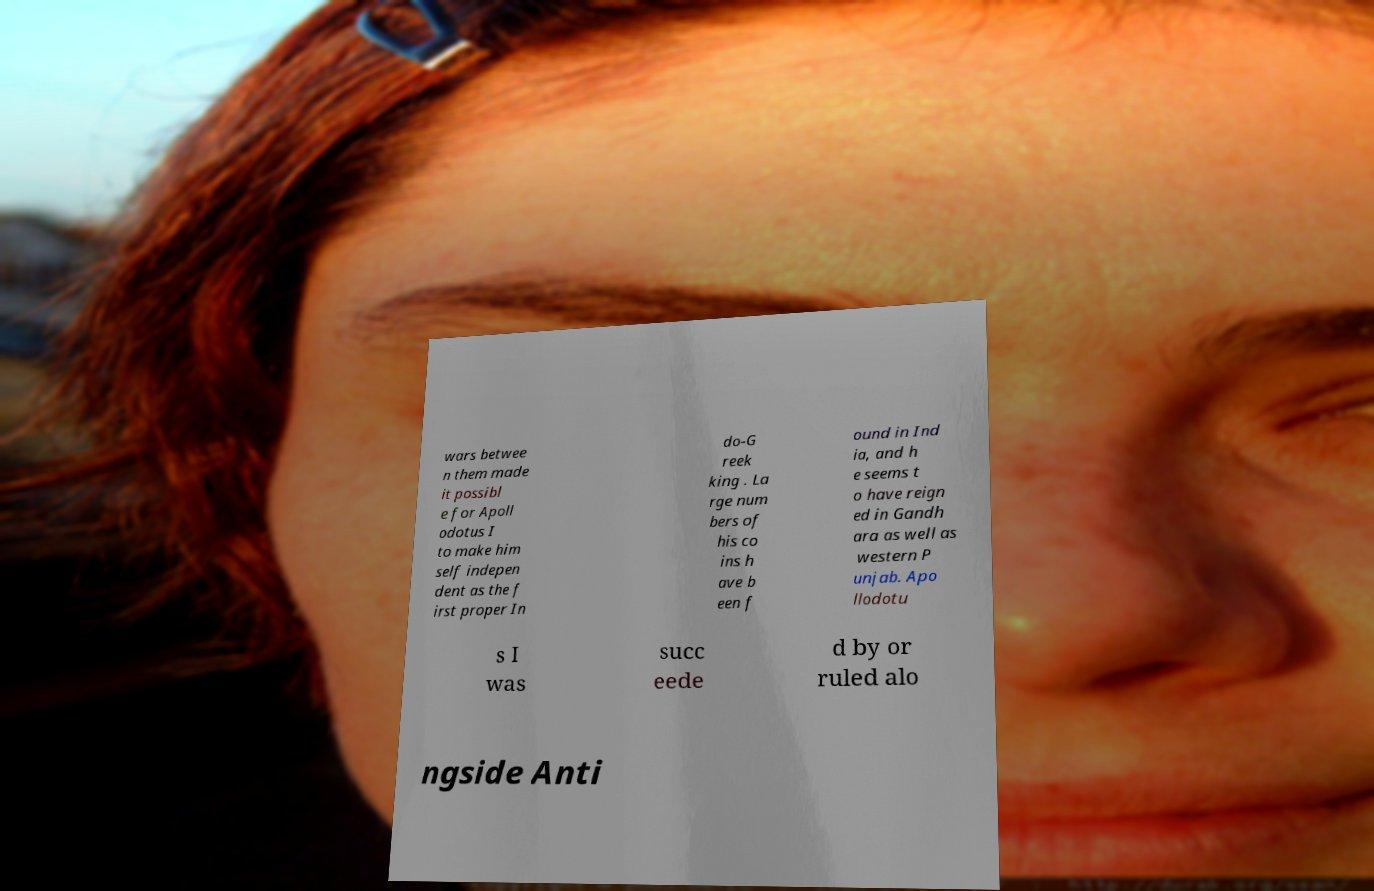Could you extract and type out the text from this image? wars betwee n them made it possibl e for Apoll odotus I to make him self indepen dent as the f irst proper In do-G reek king . La rge num bers of his co ins h ave b een f ound in Ind ia, and h e seems t o have reign ed in Gandh ara as well as western P unjab. Apo llodotu s I was succ eede d by or ruled alo ngside Anti 